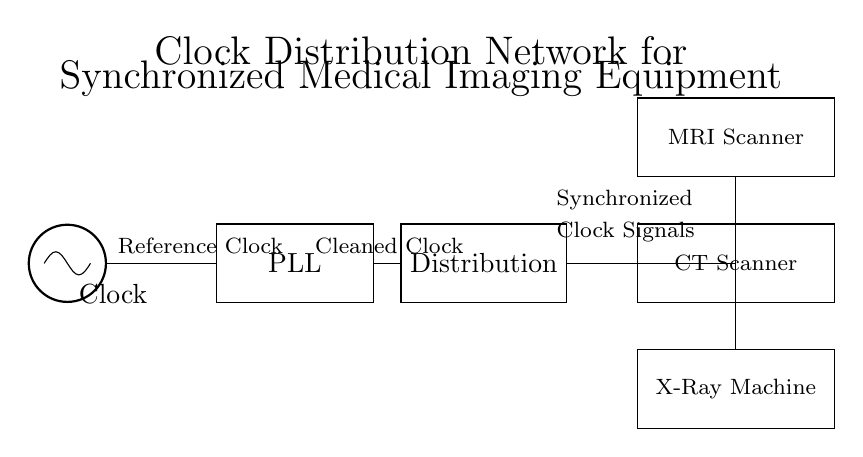What is the primary function of the PLL in this circuit? The PLL, or Phase-Locked Loop, is tasked with cleaning and stabilizing the clock signal received from the oscillator. It ensures that the distributed clock signals are synchronized and of good quality for the medical imaging equipment.
Answer: Cleaning and stabilizing clock signal What type of medical equipment is depicted in the circuit? The circuit shows three types of medical imaging equipment: MRI Scanner, CT Scanner, and X-Ray Machine. They are all designed to rely on the synchronized clock signals created by the distribution network.
Answer: MRI Scanner, CT Scanner, X-Ray Machine How many output connections are there from the distribution block? From the distribution block, there are three connections going to the medical imaging equipment. Each piece of equipment receives a synchronized clock signal from the distribution.
Answer: Three What is the purpose of the clock distribution in this circuit? The purpose of the clock distribution is to ensure that all connected medical imaging devices operate in sync with a stable clock signal, thus improving the reliability and accuracy of the imaging processes.
Answer: Synchronization of devices What does the label “Synchronized” indicate in the circuit? The label “Synchronized” indicates that the clock signals distributed from the distribution block have been designed to ensure that all output connections provide a timed and coherent signal to each medical imaging equipment, facilitating their proper function.
Answer: Timed and coherent signals What is the starting component of the clock distribution network? The starting component of the clock distribution network is the oscillator, which generates the reference clock that drives the entire system.
Answer: Oscillator 